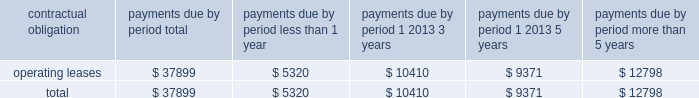As of december 31 , 2006 , we also leased an office and laboratory facility in connecticut , additional office , distribution and storage facilities in san diego , and four foreign facilities located in japan , singapore , china and the netherlands under non-cancelable operating leases that expire at various times through july 2011 .
These leases contain renewal options ranging from one to five years .
As of december 31 , 2006 , our contractual obligations were ( in thousands ) : contractual obligation total less than 1 year 1 2013 3 years 1 2013 5 years more than 5 years .
The above table does not include orders for goods and services entered into in the normal course of business that are not enforceable or legally binding .
Item 7a .
Quantitative and qualitative disclosures about market risk .
Interest rate sensitivity our exposure to market risk for changes in interest rates relates primarily to our investment portfolio .
The fair market value of fixed rate securities may be adversely impacted by fluctuations in interest rates while income earned on floating rate securities may decline as a result of decreases in interest rates .
Under our current policies , we do not use interest rate derivative instruments to manage exposure to interest rate changes .
We attempt to ensure the safety and preservation of our invested principal funds by limiting default risk , market risk and reinvestment risk .
We mitigate default risk by investing in investment grade securities .
We have historically maintained a relatively short average maturity for our investment portfolio , and we believe a hypothetical 100 basis point adverse move in interest rates along the entire interest rate yield curve would not materially affect the fair value of our interest sensitive financial instruments .
Foreign currency exchange risk although most of our revenue is realized in u.s .
Dollars , some portions of our revenue are realized in foreign currencies .
As a result , our financial results could be affected by factors such as changes in foreign currency exchange rates or weak economic conditions in foreign markets .
The functional currencies of our subsidiaries are their respective local currencies .
Accordingly , the accounts of these operations are translated from the local currency to the u.s .
Dollar using the current exchange rate in effect at the balance sheet date for the balance sheet accounts , and using the average exchange rate during the period for revenue and expense accounts .
The effects of translation are recorded in accumulated other comprehensive income as a separate component of stockholders 2019 equity. .
What percentage of total contractual obligations are due in more than 5 years? 
Computations: (12798 / 37899)
Answer: 0.33769. 